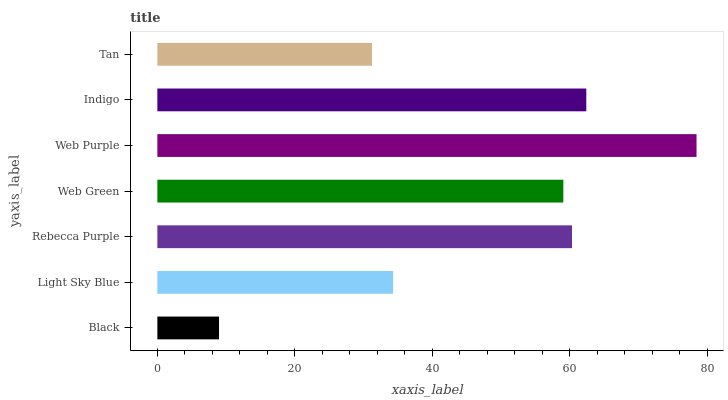Is Black the minimum?
Answer yes or no. Yes. Is Web Purple the maximum?
Answer yes or no. Yes. Is Light Sky Blue the minimum?
Answer yes or no. No. Is Light Sky Blue the maximum?
Answer yes or no. No. Is Light Sky Blue greater than Black?
Answer yes or no. Yes. Is Black less than Light Sky Blue?
Answer yes or no. Yes. Is Black greater than Light Sky Blue?
Answer yes or no. No. Is Light Sky Blue less than Black?
Answer yes or no. No. Is Web Green the high median?
Answer yes or no. Yes. Is Web Green the low median?
Answer yes or no. Yes. Is Web Purple the high median?
Answer yes or no. No. Is Black the low median?
Answer yes or no. No. 